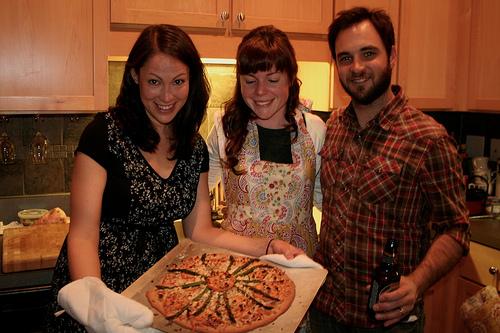Is the pizza whole?
Write a very short answer. Yes. What food is this?
Give a very brief answer. Pizza. Is the man wearing plaid?
Give a very brief answer. Yes. 